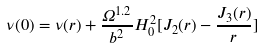Convert formula to latex. <formula><loc_0><loc_0><loc_500><loc_500>\nu ( 0 ) = \nu ( r ) + \frac { \Omega ^ { 1 . 2 } } { b ^ { 2 } } H _ { 0 } ^ { 2 } [ J _ { 2 } ( r ) - \frac { J _ { 3 } ( r ) } { r } ]</formula> 